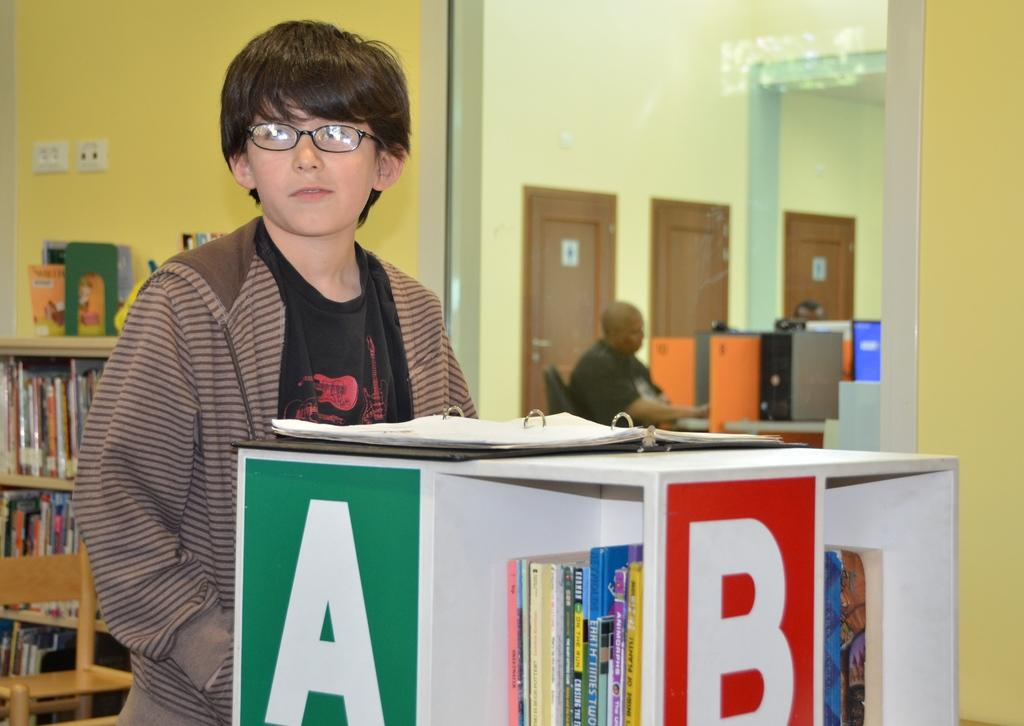<image>
Render a clear and concise summary of the photo. A boy in a brown stripped jacket stands in front of a book display case. 